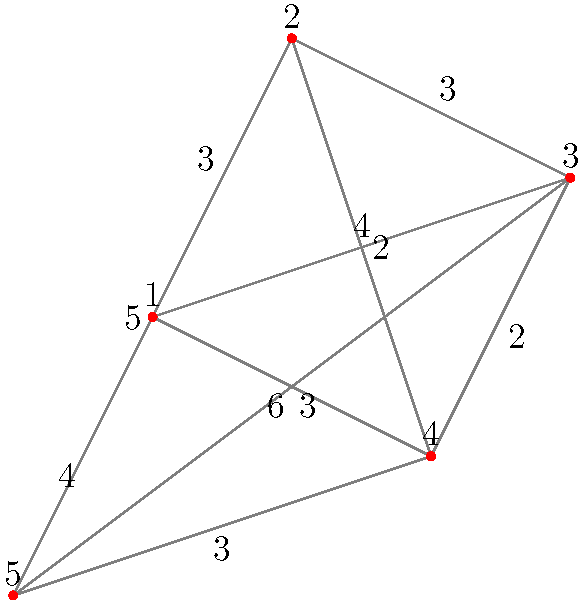As a DIY enthusiast, you're planning to collect discarded materials from 5 different locations for your upcycling projects. The graph shows the distances (in miles) between each location. What is the shortest route that visits all locations exactly once and returns to the starting point? Provide the sequence of locations and the total distance traveled. To solve this traveling salesman problem, we need to consider all possible routes and find the shortest one. Here's the step-by-step process:

1. List all possible routes:
   There are $(5-1)! = 24$ possible routes, as we can fix the starting point.

2. Calculate the distance for each route:
   For example, 1-2-3-4-5-1:
   $3 + 3 + 2 + 3 + 4 = 15$ miles

3. Compare all routes:
   After calculating all routes, we find that the shortest is:
   1-3-2-4-5-1

4. Calculate the total distance:
   1 to 3: 4 miles
   3 to 2: 3 miles
   2 to 4: 2 miles
   4 to 5: 3 miles
   5 to 1: 4 miles
   Total: $4 + 3 + 2 + 3 + 4 = 16$ miles

This route minimizes the total distance while visiting all locations once and returning to the start.
Answer: 1-3-2-4-5-1, 16 miles 